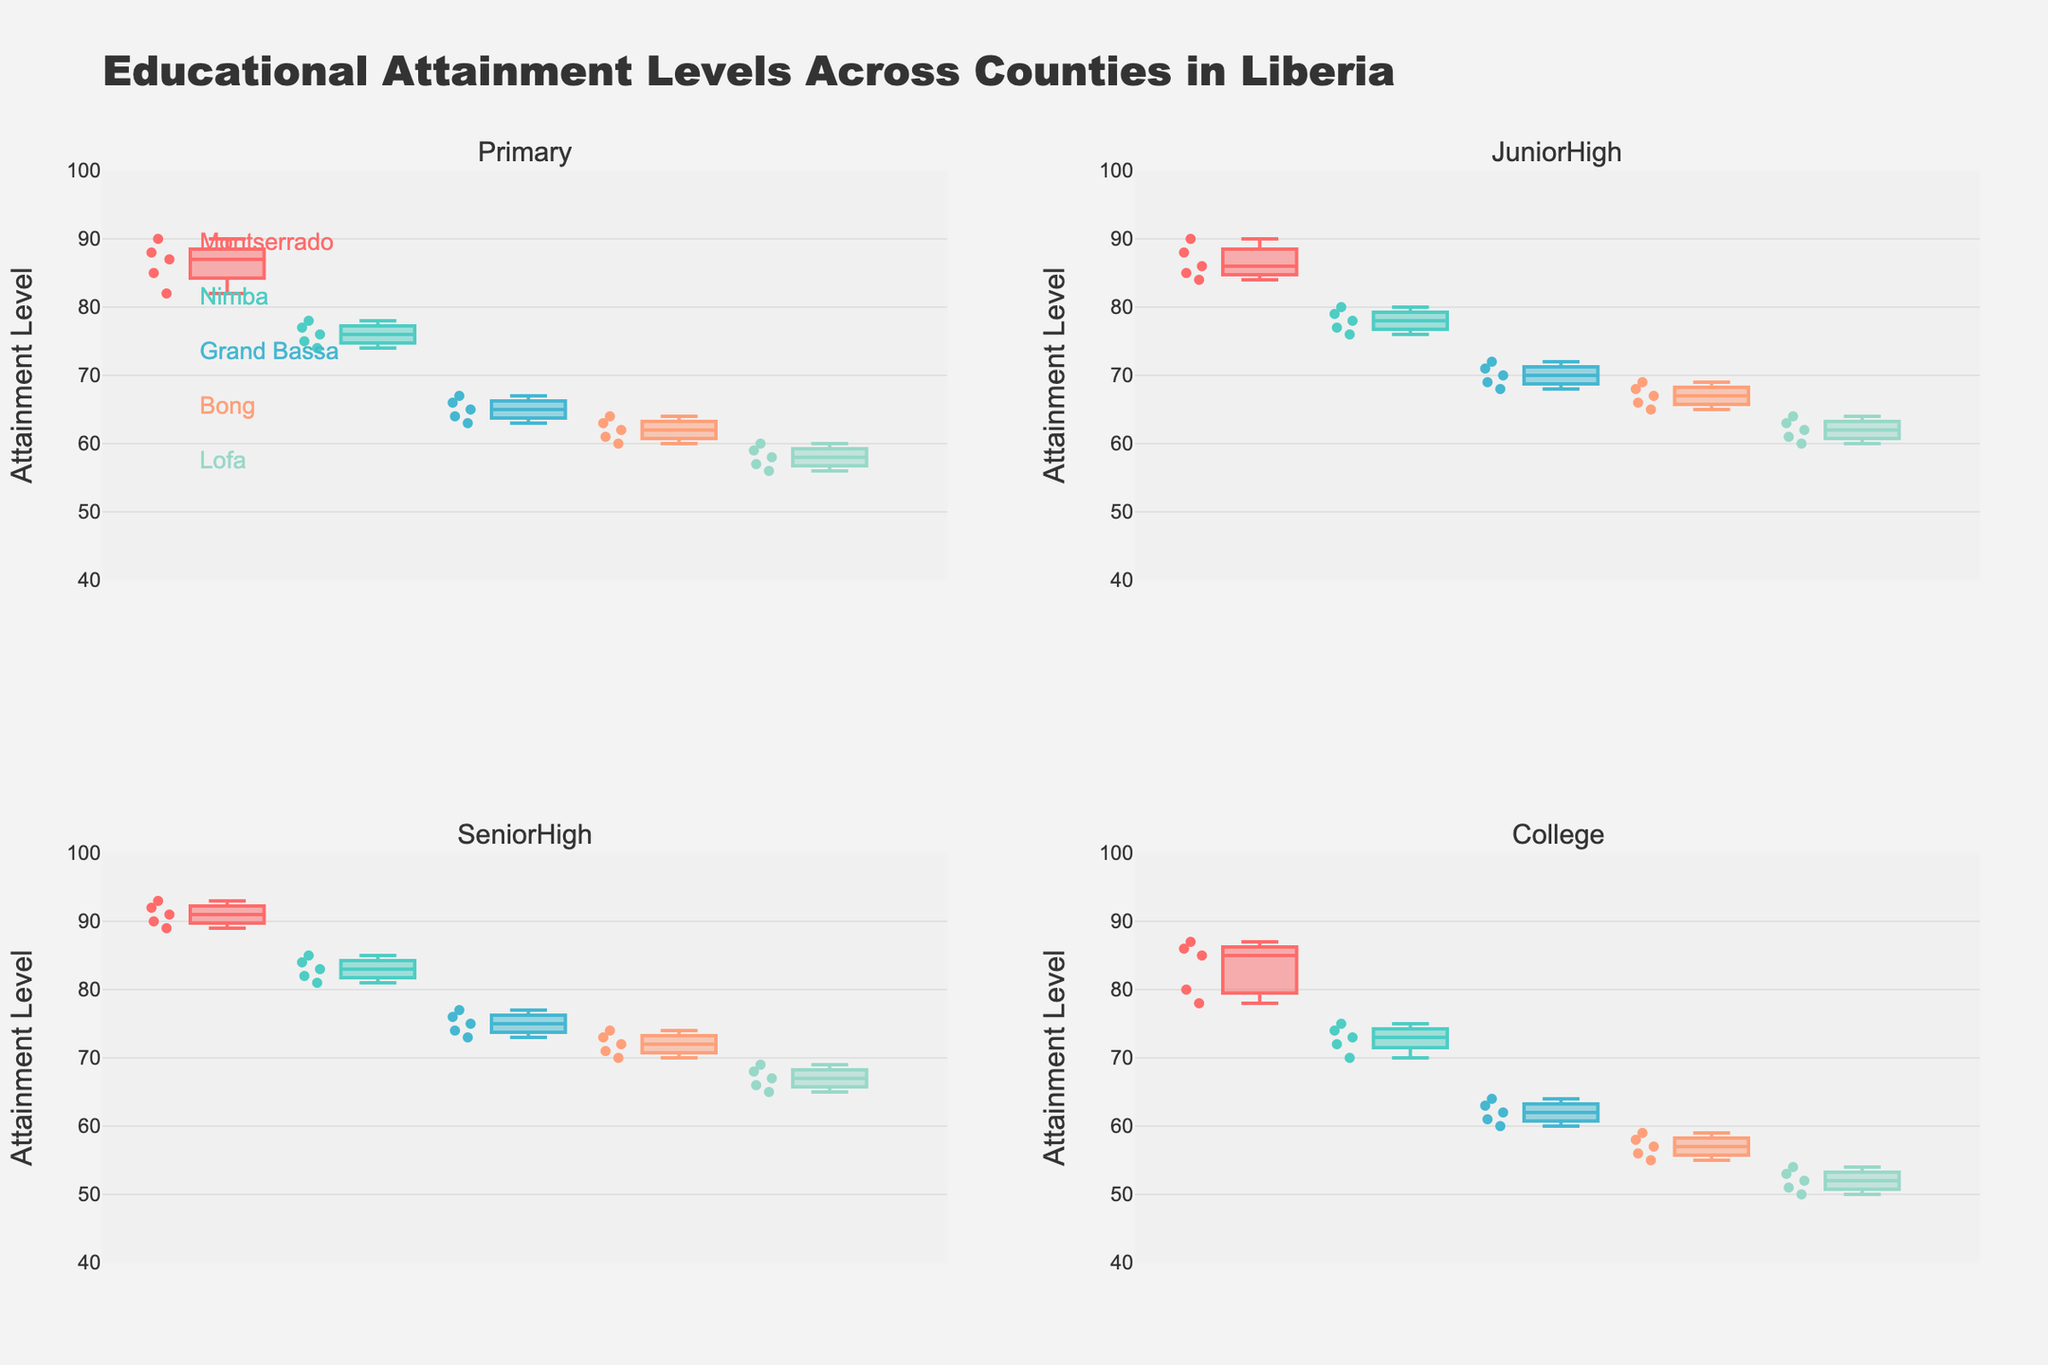How many counties are represented in the plots? The plot shows data from multiple counties. By looking at the annotations listing the county names, we can count the number of different names.
Answer: 5 Which county has the highest median educational attainment in the Primary category? In the Primary category subplot (top-left), observe the median lines within the box plots for each county. Montserrado has the highest median as its median line is higher than the rest.
Answer: Montserrado What is the approximate interquartile range (IQR) for Junior High in Bong? In the Junior High subplot (top-right), find the Bong box plot. The IQR is the difference between the upper quartile (top of the box) and the lower quartile (bottom of the box). Here, it spans from around 67 to 65.
Answer: 2 Which level of educational attainment shows the widest spread (range) in Grand Bassa? Evaluate the range (difference between maximum and minimum values) within the Grand Bassa box plots across all subplots. The widest spread happens where the whiskers (lines extending from the box) cover the largest vertical distance. The College category (bottom-right) shows the widest spread, from about 60 to 64.
Answer: College How do the median educational attainment levels in Senior High compare between Nimba and Lofa? Check the Senior High category subplot (bottom-left) and compare the median lines of Nimba and Lofa. The median for Nimba is higher than that of Lofa.
Answer: Nimba has a higher median Which county shows the highest variability in College attainment? Look at the College subplot (bottom-right) and observe the boxes and whiskers for each county. The county with the most extended range (highest variability) is Montserrado, as its whiskers span a larger distance compared to others.
Answer: Montserrado What is the median value for Senior High attainment in the plotted data? In the Senior High subplot (bottom-left), identify the median lines of all counties' box plots. They visually align around the mid-80s range.
Answer: Around 85 Are there any outliers in the Primary education category for Lofa? Find the Lofa box plot in the Primary category subplot (top-left). Look for any data points that are outside the whiskers. There are no apparent outliers as all points fall within the whisker range.
Answer: No What is the average median attainment level across all counties for College education? Identify the median lines of each county’s box plot in the College subplot (bottom-right). These medians appear to be around 53, 55, 56, 57, and 60. The average is (53 + 55 + 56 + 57 + 60) / 5 = 56.2.
Answer: 56.2 Which educational level shows the least variation in attainment levels among the counties? Compare the ranges (whiskers' lengths) of box plots across all educational categories. Junior High (top-right) generally shows the least variation, as the whiskers are shorter and boxes are more compact compared to other categories.
Answer: Junior High 